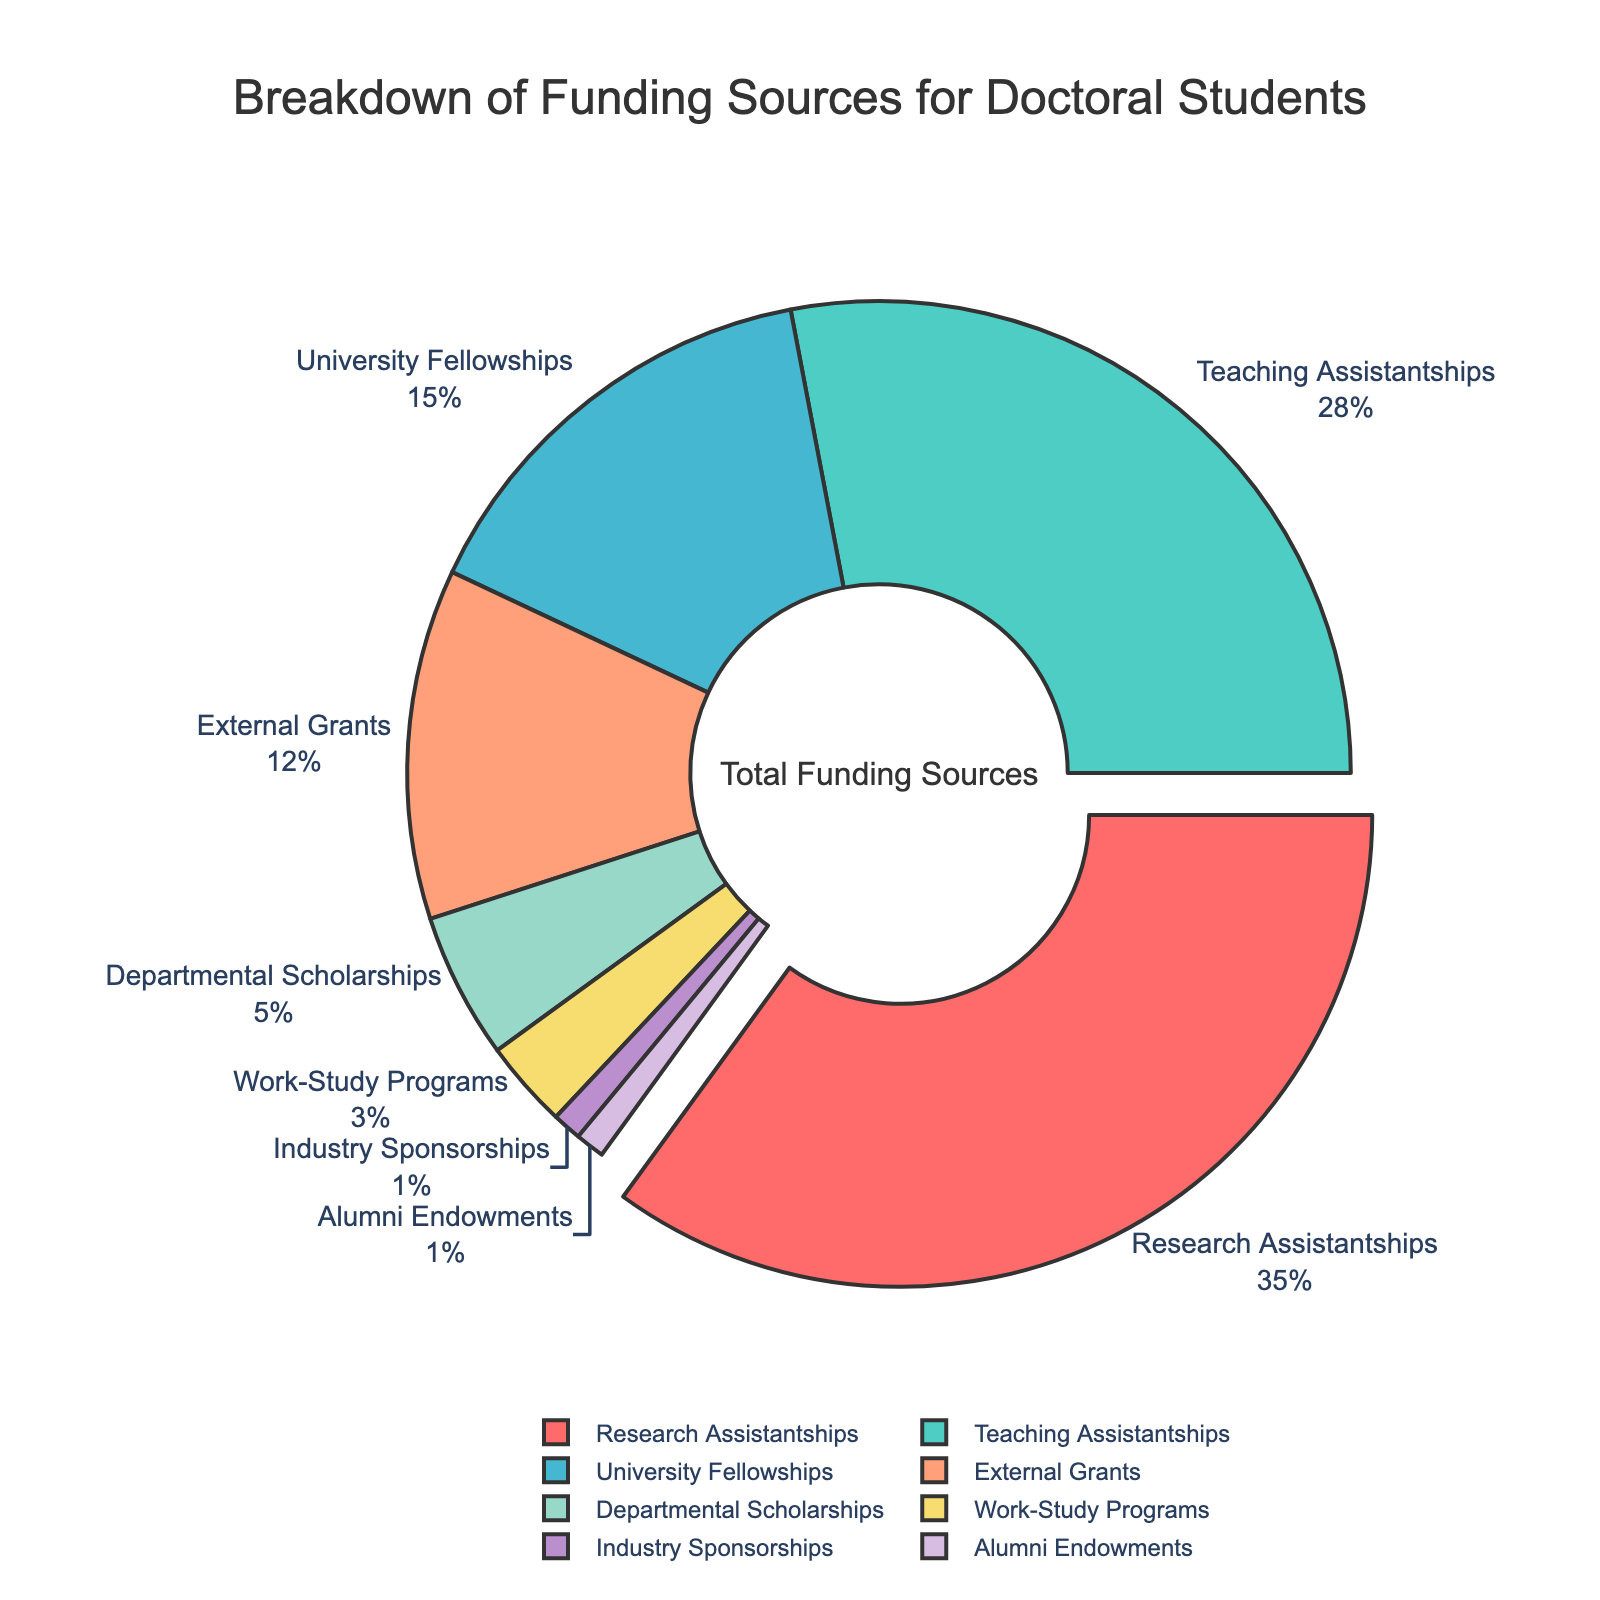What is the largest source of funding for doctoral students? By examining the figure, the segment with the largest percentage is identified, which is Research Assistantships at 35%.
Answer: Research Assistantships What percentage of funding comes from external sources (External Grants and Industry Sponsorships combined)? External Grants contribute 12% and Industry Sponsorships make up 1%. Adding these, 12 + 1 = 13%.
Answer: 13% Which funding source has a percentage closest to 10%? By scanning the figure, the closest value to 10% is External Grants, which have a percentage of 12%.
Answer: External Grants Are the combined percentages of Teaching Assistantships and University Fellowships greater or less than 50%? Teaching Assistantships are 28% and University Fellowships are 15%, summing these gives 28 + 15 = 43%. Since 43% is less than 50%, the combined percentage is less.
Answer: Less What is the difference in funding percentage between Research Assistantships and Teaching Assistantships? Research Assistantships have 35%, and Teaching Assistantships have 28%. The difference is 35 - 28 = 7%.
Answer: 7% Which funding source is represented by the smallest segment in the pie chart? By observing the pie chart, Industry Sponsorships and Alumni Endowments both have the smallest segments at 1%.
Answer: Industry Sponsorships and Alumni Endowments How many of the funding sources have a percentage greater than 10%? The segments greater than 10% are Research Assistantships (35%), Teaching Assistantships (28%), University Fellowships (15%), and External Grants (12%). Thus, 4 funding sources exceed 10%.
Answer: 4 What are the colors representing Teaching Assistantships and Work-Study Programs in the pie chart? In the figure, Teaching Assistantships should be in turquoise, and Work-Study Programs should be in yellow.
Answer: Turquoise and Yellow What is the total percentage of funding from all sources excluding Work-Study Programs and Alumni Endowments? Excluding Work-Study Programs (3%) and Alumni Endowments (1%), the total percentage sums up the rest: 35+28+15+12+5+1 = 96%.
Answer: 96% Which funding sources have a percentage that, when summed, equals the percentage of Research Assistantships? Research Assistantships have 35%. Summing University Fellowships (15%), External Grants (12%), and Departmental Scholarships (5%) equals 15+12+5 = 32%, not enough. Adding Work-Study Programs (3%) makes 35%. Thus, the sum is University Fellowships, External Grants, Departmental Scholarships, and Work-Study Programs.
Answer: University Fellowships, External Grants, Departmental Scholarships, Work-Study Programs 